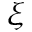Convert formula to latex. <formula><loc_0><loc_0><loc_500><loc_500>\xi</formula> 